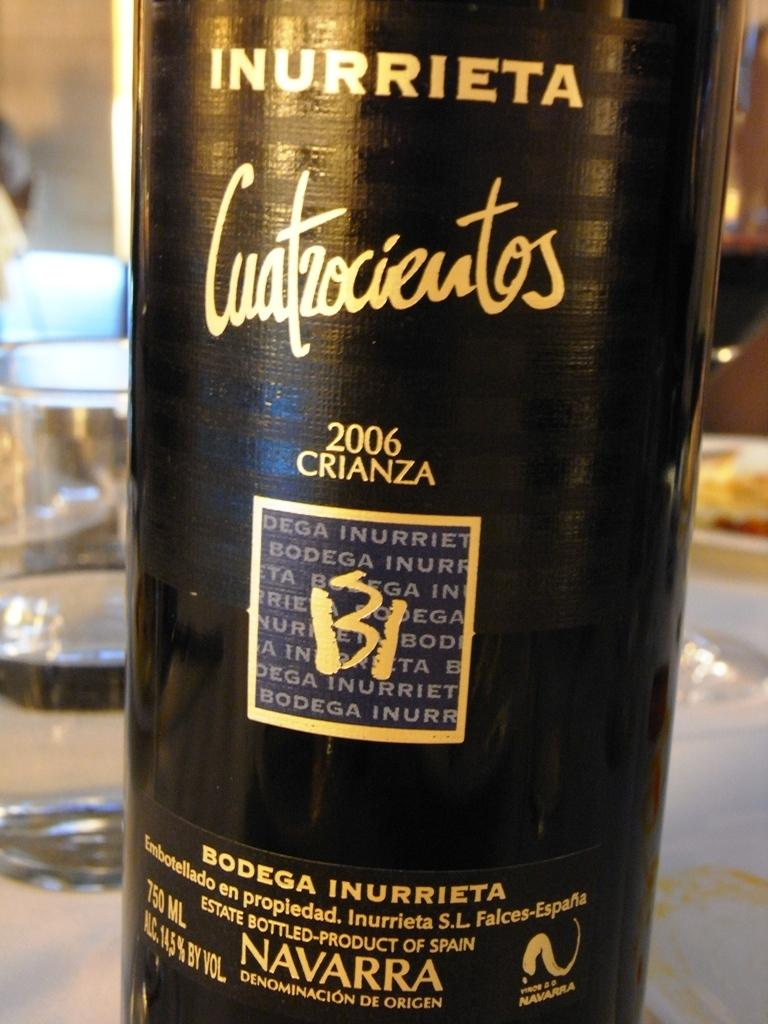<image>
Offer a succinct explanation of the picture presented. A 2006 bottle of Spanish Crianza wine sits on a table. 